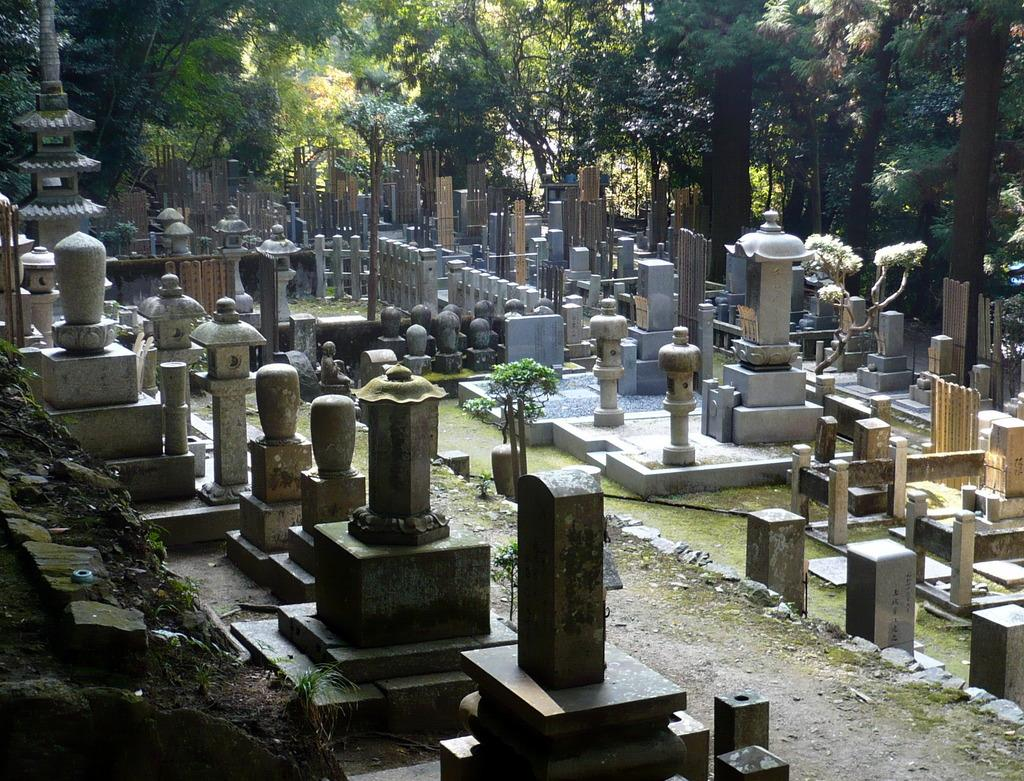What type of location is depicted in the image? The image depicts a cemetery. What can be observed about the tombstones in the cemetery? The tombstones have different shapes and sizes. What natural elements are present in the image? There are many trees surrounding the cemetery. What type of liquid is being poured on the governor's head in the image? There is no governor or liquid being poured in the image; it depicts a cemetery with tombstones and trees. 